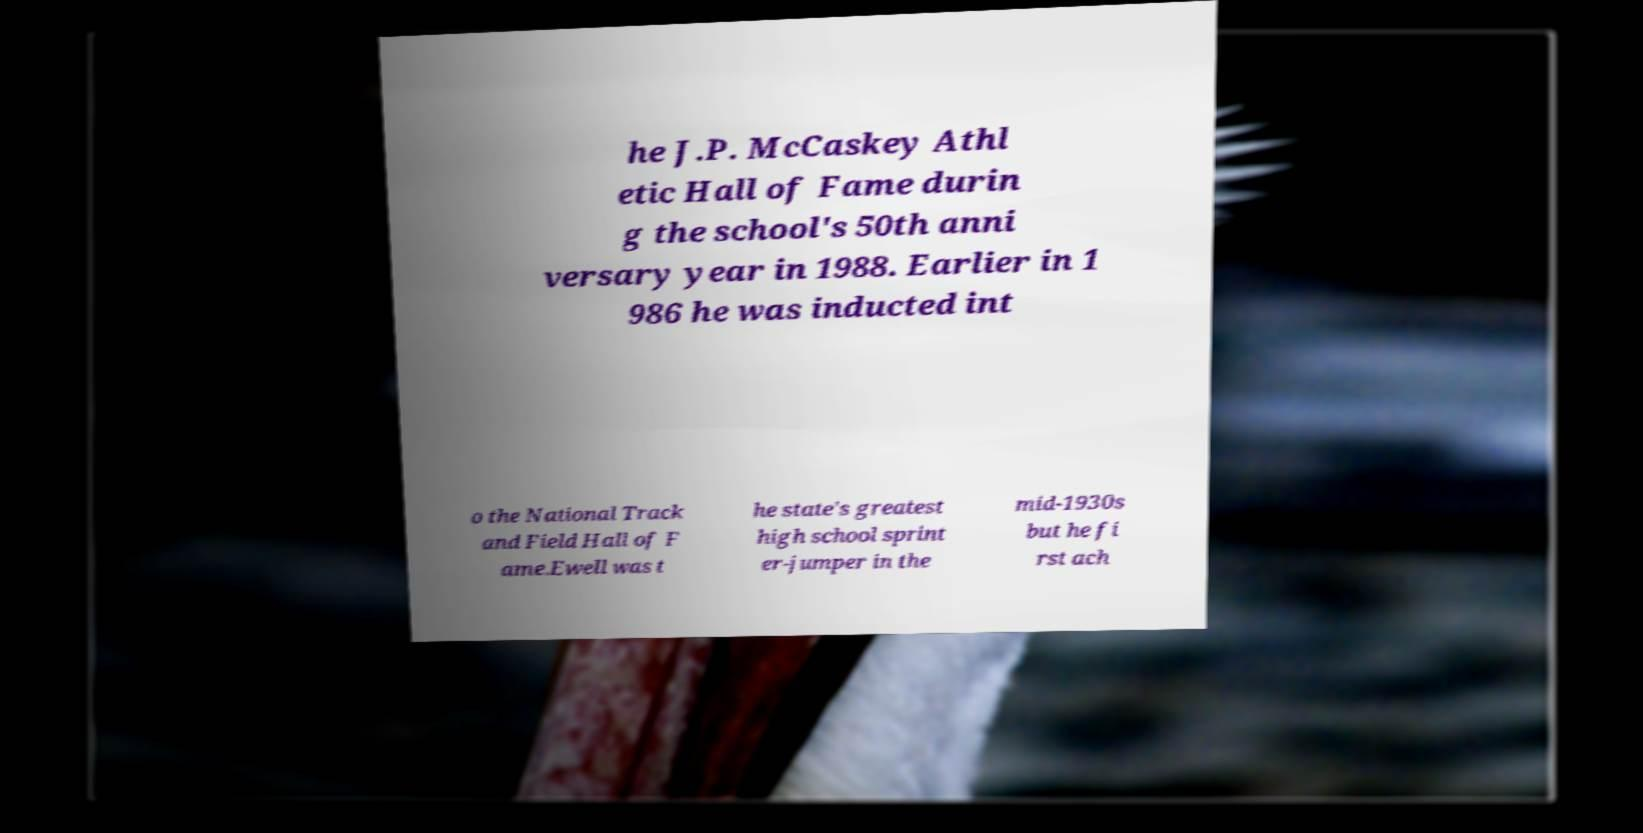Could you assist in decoding the text presented in this image and type it out clearly? he J.P. McCaskey Athl etic Hall of Fame durin g the school's 50th anni versary year in 1988. Earlier in 1 986 he was inducted int o the National Track and Field Hall of F ame.Ewell was t he state's greatest high school sprint er-jumper in the mid-1930s but he fi rst ach 